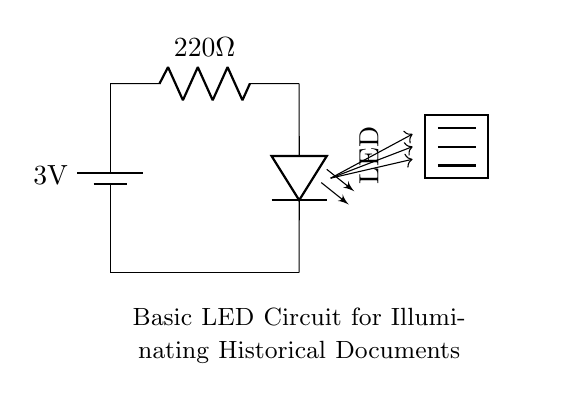What is the voltage of this circuit? The circuit shows a battery marked with a voltage of 3 volts connected in series with other components. Therefore, the total voltage of the circuit is 3 volts, which is the value indicated on the battery.
Answer: 3 volts What is the resistance in this circuit? The circuit includes a resistor labeled with a value of 220 ohms. This is the resistance that is part of the circuit, serving to limit the current flowing through it.
Answer: 220 ohms What type of light source does this circuit use? The circuit diagram includes a component labeled as LED. This indicates that the light source used to illuminate the historical documents is a light-emitting diode.
Answer: LED How many components are in this circuit? Upon examining the circuit, it consists of three main components: a battery, a resistor, and an LED. Therefore, the total number of components in this circuit is three.
Answer: Three What is the purpose of the resistor in this circuit? The resistor is used to limit the flow of current through the circuit to prevent the LED from drawing too much current, which could damage it. Thus, the resistor's role is essential for safe operation.
Answer: Current limiting What happens if the resistor is removed from the circuit? Removing the resistor would allow excessive current to flow through the LED, likely causing it to burn out due to overheating. This demonstrates the critical role of the resistor in protecting the LED from damage.
Answer: LED burn-out What is the primary use of this circuit? The circuit is designed to provide illumination to historical documents by utilizing the LED as a light source, making it suitable for displaying or reading documents in low light conditions.
Answer: Document illumination 